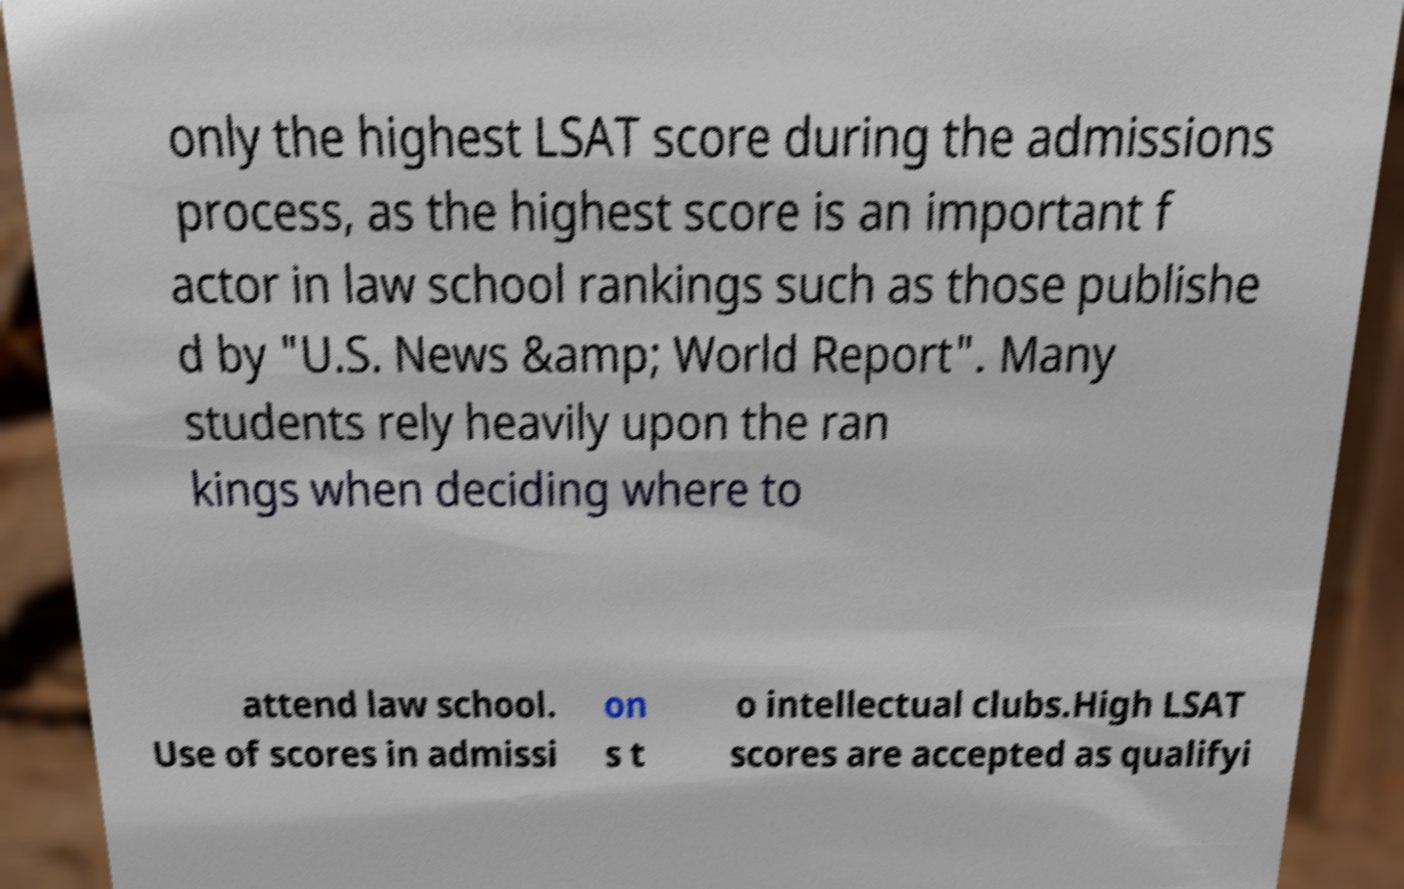Please read and relay the text visible in this image. What does it say? only the highest LSAT score during the admissions process, as the highest score is an important f actor in law school rankings such as those publishe d by "U.S. News &amp; World Report". Many students rely heavily upon the ran kings when deciding where to attend law school. Use of scores in admissi on s t o intellectual clubs.High LSAT scores are accepted as qualifyi 